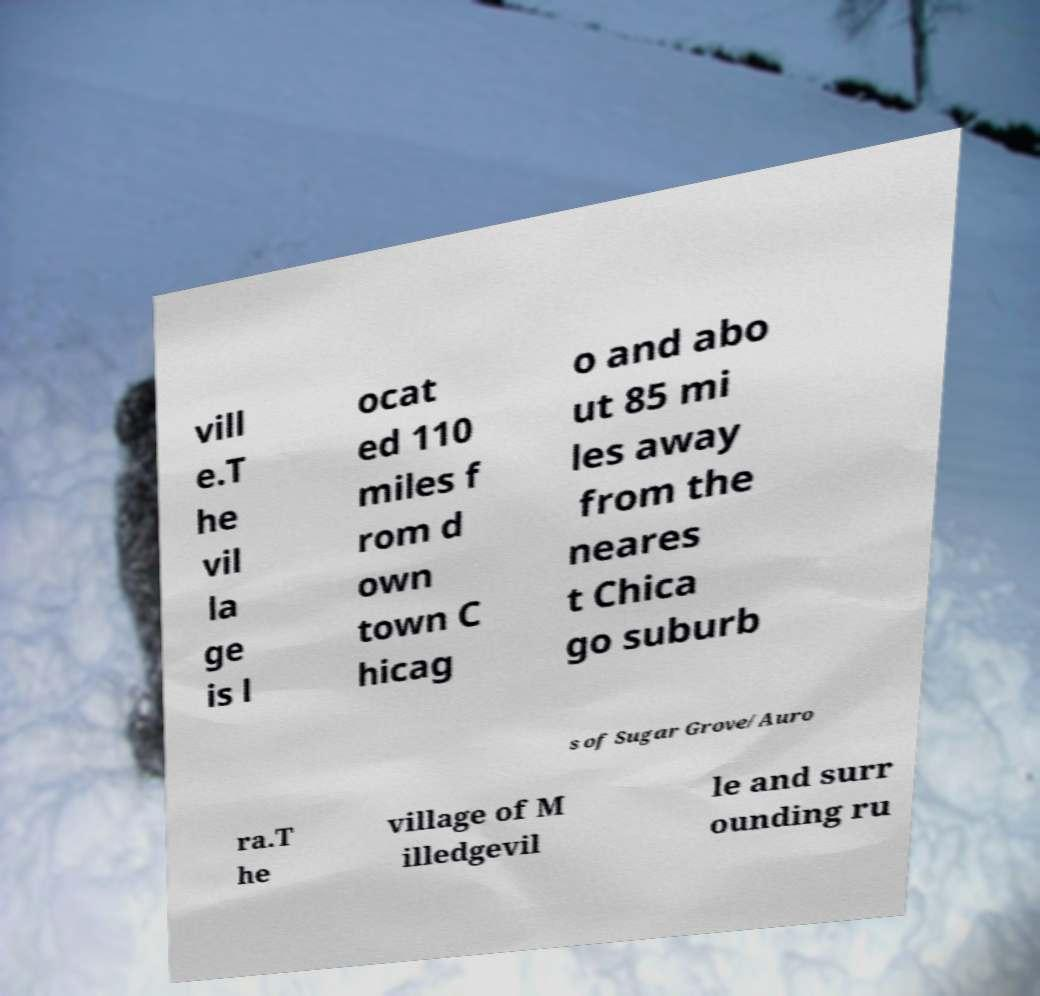Can you accurately transcribe the text from the provided image for me? vill e.T he vil la ge is l ocat ed 110 miles f rom d own town C hicag o and abo ut 85 mi les away from the neares t Chica go suburb s of Sugar Grove/Auro ra.T he village of M illedgevil le and surr ounding ru 